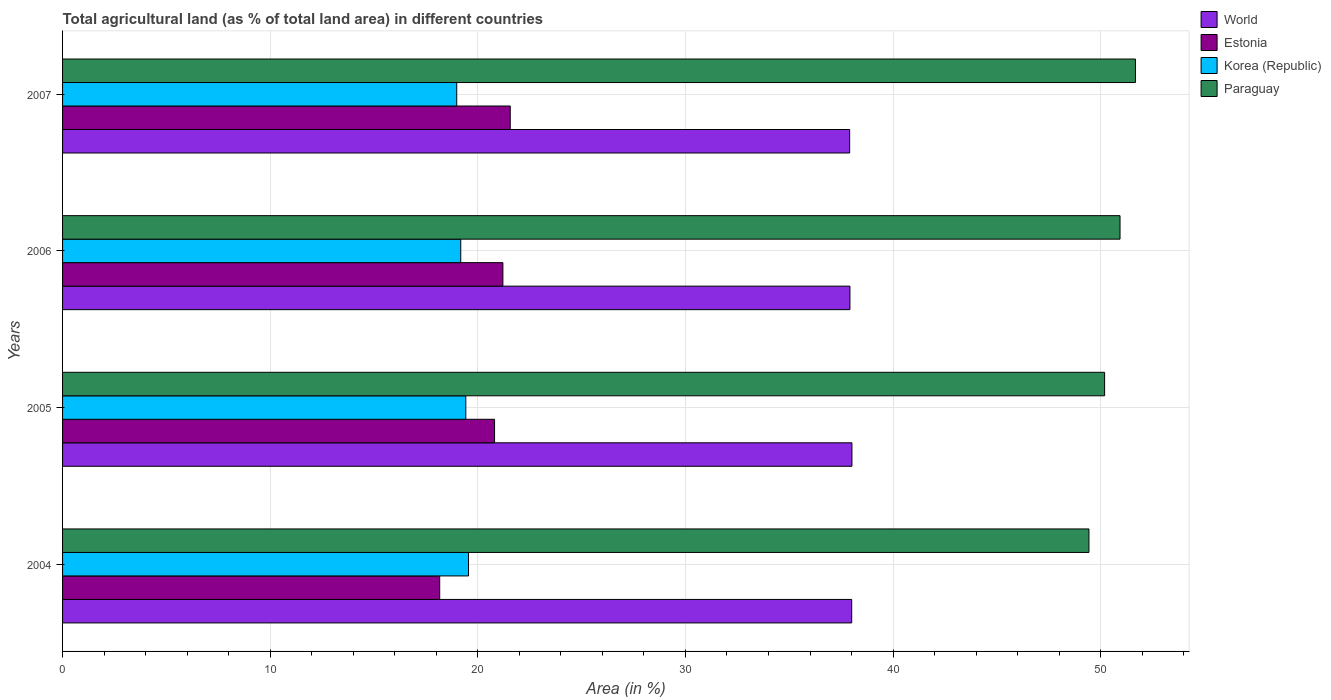How many different coloured bars are there?
Provide a succinct answer. 4. How many groups of bars are there?
Make the answer very short. 4. How many bars are there on the 2nd tick from the top?
Your answer should be very brief. 4. What is the label of the 4th group of bars from the top?
Give a very brief answer. 2004. What is the percentage of agricultural land in Estonia in 2006?
Make the answer very short. 21.21. Across all years, what is the maximum percentage of agricultural land in Paraguay?
Your response must be concise. 51.67. Across all years, what is the minimum percentage of agricultural land in Paraguay?
Offer a very short reply. 49.43. In which year was the percentage of agricultural land in Estonia minimum?
Keep it short and to the point. 2004. What is the total percentage of agricultural land in World in the graph?
Ensure brevity in your answer.  151.86. What is the difference between the percentage of agricultural land in Korea (Republic) in 2005 and that in 2007?
Make the answer very short. 0.44. What is the difference between the percentage of agricultural land in World in 2005 and the percentage of agricultural land in Estonia in 2007?
Ensure brevity in your answer.  16.46. What is the average percentage of agricultural land in Estonia per year?
Provide a succinct answer. 20.44. In the year 2007, what is the difference between the percentage of agricultural land in Estonia and percentage of agricultural land in World?
Make the answer very short. -16.35. What is the ratio of the percentage of agricultural land in Estonia in 2004 to that in 2007?
Give a very brief answer. 0.84. Is the percentage of agricultural land in Paraguay in 2005 less than that in 2007?
Your response must be concise. Yes. Is the difference between the percentage of agricultural land in Estonia in 2004 and 2007 greater than the difference between the percentage of agricultural land in World in 2004 and 2007?
Keep it short and to the point. No. What is the difference between the highest and the second highest percentage of agricultural land in Paraguay?
Your answer should be compact. 0.74. What is the difference between the highest and the lowest percentage of agricultural land in Paraguay?
Your answer should be compact. 2.24. Is it the case that in every year, the sum of the percentage of agricultural land in Estonia and percentage of agricultural land in Korea (Republic) is greater than the sum of percentage of agricultural land in Paraguay and percentage of agricultural land in World?
Your response must be concise. No. What does the 1st bar from the bottom in 2005 represents?
Your answer should be very brief. World. Are all the bars in the graph horizontal?
Offer a terse response. Yes. What is the difference between two consecutive major ticks on the X-axis?
Provide a short and direct response. 10. Are the values on the major ticks of X-axis written in scientific E-notation?
Offer a terse response. No. Does the graph contain any zero values?
Your answer should be compact. No. Where does the legend appear in the graph?
Offer a very short reply. Top right. How many legend labels are there?
Make the answer very short. 4. How are the legend labels stacked?
Keep it short and to the point. Vertical. What is the title of the graph?
Ensure brevity in your answer.  Total agricultural land (as % of total land area) in different countries. Does "Korea (Republic)" appear as one of the legend labels in the graph?
Make the answer very short. Yes. What is the label or title of the X-axis?
Offer a very short reply. Area (in %). What is the Area (in %) in World in 2004?
Give a very brief answer. 38.01. What is the Area (in %) in Estonia in 2004?
Your answer should be compact. 18.16. What is the Area (in %) of Korea (Republic) in 2004?
Keep it short and to the point. 19.55. What is the Area (in %) of Paraguay in 2004?
Your answer should be compact. 49.43. What is the Area (in %) of World in 2005?
Provide a succinct answer. 38.02. What is the Area (in %) of Estonia in 2005?
Offer a terse response. 20.81. What is the Area (in %) of Korea (Republic) in 2005?
Ensure brevity in your answer.  19.42. What is the Area (in %) of Paraguay in 2005?
Your answer should be compact. 50.19. What is the Area (in %) of World in 2006?
Make the answer very short. 37.92. What is the Area (in %) in Estonia in 2006?
Your answer should be very brief. 21.21. What is the Area (in %) of Korea (Republic) in 2006?
Keep it short and to the point. 19.18. What is the Area (in %) of Paraguay in 2006?
Keep it short and to the point. 50.93. What is the Area (in %) of World in 2007?
Provide a short and direct response. 37.91. What is the Area (in %) in Estonia in 2007?
Offer a terse response. 21.56. What is the Area (in %) of Korea (Republic) in 2007?
Your answer should be very brief. 18.98. What is the Area (in %) of Paraguay in 2007?
Offer a terse response. 51.67. Across all years, what is the maximum Area (in %) of World?
Ensure brevity in your answer.  38.02. Across all years, what is the maximum Area (in %) in Estonia?
Offer a very short reply. 21.56. Across all years, what is the maximum Area (in %) in Korea (Republic)?
Offer a very short reply. 19.55. Across all years, what is the maximum Area (in %) of Paraguay?
Your answer should be compact. 51.67. Across all years, what is the minimum Area (in %) of World?
Keep it short and to the point. 37.91. Across all years, what is the minimum Area (in %) of Estonia?
Offer a very short reply. 18.16. Across all years, what is the minimum Area (in %) in Korea (Republic)?
Give a very brief answer. 18.98. Across all years, what is the minimum Area (in %) of Paraguay?
Make the answer very short. 49.43. What is the total Area (in %) of World in the graph?
Offer a terse response. 151.86. What is the total Area (in %) in Estonia in the graph?
Offer a terse response. 81.74. What is the total Area (in %) of Korea (Republic) in the graph?
Offer a terse response. 77.14. What is the total Area (in %) of Paraguay in the graph?
Ensure brevity in your answer.  202.23. What is the difference between the Area (in %) in World in 2004 and that in 2005?
Your answer should be very brief. -0.01. What is the difference between the Area (in %) in Estonia in 2004 and that in 2005?
Offer a terse response. -2.64. What is the difference between the Area (in %) of Korea (Republic) in 2004 and that in 2005?
Keep it short and to the point. 0.13. What is the difference between the Area (in %) in Paraguay in 2004 and that in 2005?
Provide a succinct answer. -0.76. What is the difference between the Area (in %) of World in 2004 and that in 2006?
Offer a very short reply. 0.08. What is the difference between the Area (in %) in Estonia in 2004 and that in 2006?
Provide a short and direct response. -3.04. What is the difference between the Area (in %) in Korea (Republic) in 2004 and that in 2006?
Your answer should be compact. 0.37. What is the difference between the Area (in %) in Paraguay in 2004 and that in 2006?
Ensure brevity in your answer.  -1.5. What is the difference between the Area (in %) in World in 2004 and that in 2007?
Offer a terse response. 0.1. What is the difference between the Area (in %) in Estonia in 2004 and that in 2007?
Offer a terse response. -3.4. What is the difference between the Area (in %) of Korea (Republic) in 2004 and that in 2007?
Make the answer very short. 0.57. What is the difference between the Area (in %) of Paraguay in 2004 and that in 2007?
Provide a short and direct response. -2.24. What is the difference between the Area (in %) of World in 2005 and that in 2006?
Ensure brevity in your answer.  0.1. What is the difference between the Area (in %) of Estonia in 2005 and that in 2006?
Offer a terse response. -0.4. What is the difference between the Area (in %) in Korea (Republic) in 2005 and that in 2006?
Offer a terse response. 0.24. What is the difference between the Area (in %) in Paraguay in 2005 and that in 2006?
Provide a succinct answer. -0.74. What is the difference between the Area (in %) of World in 2005 and that in 2007?
Ensure brevity in your answer.  0.11. What is the difference between the Area (in %) of Estonia in 2005 and that in 2007?
Make the answer very short. -0.75. What is the difference between the Area (in %) in Korea (Republic) in 2005 and that in 2007?
Your answer should be compact. 0.44. What is the difference between the Area (in %) in Paraguay in 2005 and that in 2007?
Give a very brief answer. -1.49. What is the difference between the Area (in %) of World in 2006 and that in 2007?
Your answer should be very brief. 0.01. What is the difference between the Area (in %) in Estonia in 2006 and that in 2007?
Provide a succinct answer. -0.35. What is the difference between the Area (in %) in Korea (Republic) in 2006 and that in 2007?
Ensure brevity in your answer.  0.19. What is the difference between the Area (in %) of Paraguay in 2006 and that in 2007?
Provide a succinct answer. -0.74. What is the difference between the Area (in %) of World in 2004 and the Area (in %) of Estonia in 2005?
Offer a very short reply. 17.2. What is the difference between the Area (in %) of World in 2004 and the Area (in %) of Korea (Republic) in 2005?
Your answer should be compact. 18.59. What is the difference between the Area (in %) of World in 2004 and the Area (in %) of Paraguay in 2005?
Offer a very short reply. -12.18. What is the difference between the Area (in %) of Estonia in 2004 and the Area (in %) of Korea (Republic) in 2005?
Offer a terse response. -1.26. What is the difference between the Area (in %) in Estonia in 2004 and the Area (in %) in Paraguay in 2005?
Make the answer very short. -32.02. What is the difference between the Area (in %) in Korea (Republic) in 2004 and the Area (in %) in Paraguay in 2005?
Keep it short and to the point. -30.64. What is the difference between the Area (in %) of World in 2004 and the Area (in %) of Korea (Republic) in 2006?
Your answer should be compact. 18.83. What is the difference between the Area (in %) in World in 2004 and the Area (in %) in Paraguay in 2006?
Your answer should be compact. -12.92. What is the difference between the Area (in %) in Estonia in 2004 and the Area (in %) in Korea (Republic) in 2006?
Keep it short and to the point. -1.01. What is the difference between the Area (in %) of Estonia in 2004 and the Area (in %) of Paraguay in 2006?
Your response must be concise. -32.77. What is the difference between the Area (in %) in Korea (Republic) in 2004 and the Area (in %) in Paraguay in 2006?
Offer a very short reply. -31.38. What is the difference between the Area (in %) of World in 2004 and the Area (in %) of Estonia in 2007?
Ensure brevity in your answer.  16.45. What is the difference between the Area (in %) in World in 2004 and the Area (in %) in Korea (Republic) in 2007?
Your answer should be very brief. 19.02. What is the difference between the Area (in %) in World in 2004 and the Area (in %) in Paraguay in 2007?
Ensure brevity in your answer.  -13.67. What is the difference between the Area (in %) in Estonia in 2004 and the Area (in %) in Korea (Republic) in 2007?
Give a very brief answer. -0.82. What is the difference between the Area (in %) of Estonia in 2004 and the Area (in %) of Paraguay in 2007?
Ensure brevity in your answer.  -33.51. What is the difference between the Area (in %) of Korea (Republic) in 2004 and the Area (in %) of Paraguay in 2007?
Your response must be concise. -32.12. What is the difference between the Area (in %) of World in 2005 and the Area (in %) of Estonia in 2006?
Your answer should be compact. 16.81. What is the difference between the Area (in %) in World in 2005 and the Area (in %) in Korea (Republic) in 2006?
Your answer should be compact. 18.84. What is the difference between the Area (in %) of World in 2005 and the Area (in %) of Paraguay in 2006?
Your answer should be very brief. -12.91. What is the difference between the Area (in %) of Estonia in 2005 and the Area (in %) of Korea (Republic) in 2006?
Make the answer very short. 1.63. What is the difference between the Area (in %) in Estonia in 2005 and the Area (in %) in Paraguay in 2006?
Provide a short and direct response. -30.12. What is the difference between the Area (in %) of Korea (Republic) in 2005 and the Area (in %) of Paraguay in 2006?
Your response must be concise. -31.51. What is the difference between the Area (in %) of World in 2005 and the Area (in %) of Estonia in 2007?
Offer a very short reply. 16.46. What is the difference between the Area (in %) of World in 2005 and the Area (in %) of Korea (Republic) in 2007?
Give a very brief answer. 19.03. What is the difference between the Area (in %) of World in 2005 and the Area (in %) of Paraguay in 2007?
Offer a terse response. -13.65. What is the difference between the Area (in %) in Estonia in 2005 and the Area (in %) in Korea (Republic) in 2007?
Offer a terse response. 1.82. What is the difference between the Area (in %) of Estonia in 2005 and the Area (in %) of Paraguay in 2007?
Keep it short and to the point. -30.87. What is the difference between the Area (in %) of Korea (Republic) in 2005 and the Area (in %) of Paraguay in 2007?
Make the answer very short. -32.25. What is the difference between the Area (in %) in World in 2006 and the Area (in %) in Estonia in 2007?
Provide a succinct answer. 16.36. What is the difference between the Area (in %) of World in 2006 and the Area (in %) of Korea (Republic) in 2007?
Your answer should be very brief. 18.94. What is the difference between the Area (in %) in World in 2006 and the Area (in %) in Paraguay in 2007?
Ensure brevity in your answer.  -13.75. What is the difference between the Area (in %) in Estonia in 2006 and the Area (in %) in Korea (Republic) in 2007?
Ensure brevity in your answer.  2.22. What is the difference between the Area (in %) in Estonia in 2006 and the Area (in %) in Paraguay in 2007?
Your answer should be compact. -30.47. What is the difference between the Area (in %) of Korea (Republic) in 2006 and the Area (in %) of Paraguay in 2007?
Provide a short and direct response. -32.5. What is the average Area (in %) of World per year?
Provide a short and direct response. 37.97. What is the average Area (in %) of Estonia per year?
Give a very brief answer. 20.44. What is the average Area (in %) of Korea (Republic) per year?
Your answer should be very brief. 19.28. What is the average Area (in %) of Paraguay per year?
Your response must be concise. 50.56. In the year 2004, what is the difference between the Area (in %) in World and Area (in %) in Estonia?
Offer a terse response. 19.84. In the year 2004, what is the difference between the Area (in %) in World and Area (in %) in Korea (Republic)?
Your answer should be very brief. 18.46. In the year 2004, what is the difference between the Area (in %) in World and Area (in %) in Paraguay?
Offer a very short reply. -11.43. In the year 2004, what is the difference between the Area (in %) in Estonia and Area (in %) in Korea (Republic)?
Offer a terse response. -1.39. In the year 2004, what is the difference between the Area (in %) in Estonia and Area (in %) in Paraguay?
Offer a terse response. -31.27. In the year 2004, what is the difference between the Area (in %) in Korea (Republic) and Area (in %) in Paraguay?
Your response must be concise. -29.88. In the year 2005, what is the difference between the Area (in %) of World and Area (in %) of Estonia?
Provide a succinct answer. 17.21. In the year 2005, what is the difference between the Area (in %) in World and Area (in %) in Korea (Republic)?
Offer a terse response. 18.6. In the year 2005, what is the difference between the Area (in %) of World and Area (in %) of Paraguay?
Provide a succinct answer. -12.17. In the year 2005, what is the difference between the Area (in %) in Estonia and Area (in %) in Korea (Republic)?
Your response must be concise. 1.39. In the year 2005, what is the difference between the Area (in %) in Estonia and Area (in %) in Paraguay?
Give a very brief answer. -29.38. In the year 2005, what is the difference between the Area (in %) of Korea (Republic) and Area (in %) of Paraguay?
Provide a succinct answer. -30.77. In the year 2006, what is the difference between the Area (in %) in World and Area (in %) in Estonia?
Offer a terse response. 16.72. In the year 2006, what is the difference between the Area (in %) in World and Area (in %) in Korea (Republic)?
Your response must be concise. 18.74. In the year 2006, what is the difference between the Area (in %) of World and Area (in %) of Paraguay?
Provide a succinct answer. -13.01. In the year 2006, what is the difference between the Area (in %) in Estonia and Area (in %) in Korea (Republic)?
Offer a very short reply. 2.03. In the year 2006, what is the difference between the Area (in %) of Estonia and Area (in %) of Paraguay?
Make the answer very short. -29.72. In the year 2006, what is the difference between the Area (in %) in Korea (Republic) and Area (in %) in Paraguay?
Keep it short and to the point. -31.75. In the year 2007, what is the difference between the Area (in %) of World and Area (in %) of Estonia?
Offer a very short reply. 16.35. In the year 2007, what is the difference between the Area (in %) in World and Area (in %) in Korea (Republic)?
Give a very brief answer. 18.93. In the year 2007, what is the difference between the Area (in %) of World and Area (in %) of Paraguay?
Keep it short and to the point. -13.76. In the year 2007, what is the difference between the Area (in %) in Estonia and Area (in %) in Korea (Republic)?
Make the answer very short. 2.58. In the year 2007, what is the difference between the Area (in %) in Estonia and Area (in %) in Paraguay?
Keep it short and to the point. -30.11. In the year 2007, what is the difference between the Area (in %) of Korea (Republic) and Area (in %) of Paraguay?
Your answer should be very brief. -32.69. What is the ratio of the Area (in %) in Estonia in 2004 to that in 2005?
Provide a succinct answer. 0.87. What is the ratio of the Area (in %) in World in 2004 to that in 2006?
Provide a succinct answer. 1. What is the ratio of the Area (in %) of Estonia in 2004 to that in 2006?
Your answer should be compact. 0.86. What is the ratio of the Area (in %) of Korea (Republic) in 2004 to that in 2006?
Offer a very short reply. 1.02. What is the ratio of the Area (in %) in Paraguay in 2004 to that in 2006?
Offer a terse response. 0.97. What is the ratio of the Area (in %) of World in 2004 to that in 2007?
Give a very brief answer. 1. What is the ratio of the Area (in %) in Estonia in 2004 to that in 2007?
Ensure brevity in your answer.  0.84. What is the ratio of the Area (in %) in Korea (Republic) in 2004 to that in 2007?
Provide a succinct answer. 1.03. What is the ratio of the Area (in %) in Paraguay in 2004 to that in 2007?
Ensure brevity in your answer.  0.96. What is the ratio of the Area (in %) of World in 2005 to that in 2006?
Give a very brief answer. 1. What is the ratio of the Area (in %) of Estonia in 2005 to that in 2006?
Offer a terse response. 0.98. What is the ratio of the Area (in %) in Korea (Republic) in 2005 to that in 2006?
Your response must be concise. 1.01. What is the ratio of the Area (in %) in Paraguay in 2005 to that in 2006?
Ensure brevity in your answer.  0.99. What is the ratio of the Area (in %) in Estonia in 2005 to that in 2007?
Ensure brevity in your answer.  0.96. What is the ratio of the Area (in %) of Paraguay in 2005 to that in 2007?
Ensure brevity in your answer.  0.97. What is the ratio of the Area (in %) of World in 2006 to that in 2007?
Offer a terse response. 1. What is the ratio of the Area (in %) of Estonia in 2006 to that in 2007?
Your answer should be compact. 0.98. What is the ratio of the Area (in %) of Korea (Republic) in 2006 to that in 2007?
Ensure brevity in your answer.  1.01. What is the ratio of the Area (in %) of Paraguay in 2006 to that in 2007?
Make the answer very short. 0.99. What is the difference between the highest and the second highest Area (in %) of World?
Provide a short and direct response. 0.01. What is the difference between the highest and the second highest Area (in %) of Estonia?
Keep it short and to the point. 0.35. What is the difference between the highest and the second highest Area (in %) of Korea (Republic)?
Make the answer very short. 0.13. What is the difference between the highest and the second highest Area (in %) in Paraguay?
Your response must be concise. 0.74. What is the difference between the highest and the lowest Area (in %) of World?
Your response must be concise. 0.11. What is the difference between the highest and the lowest Area (in %) in Estonia?
Give a very brief answer. 3.4. What is the difference between the highest and the lowest Area (in %) of Korea (Republic)?
Your answer should be compact. 0.57. What is the difference between the highest and the lowest Area (in %) in Paraguay?
Provide a short and direct response. 2.24. 